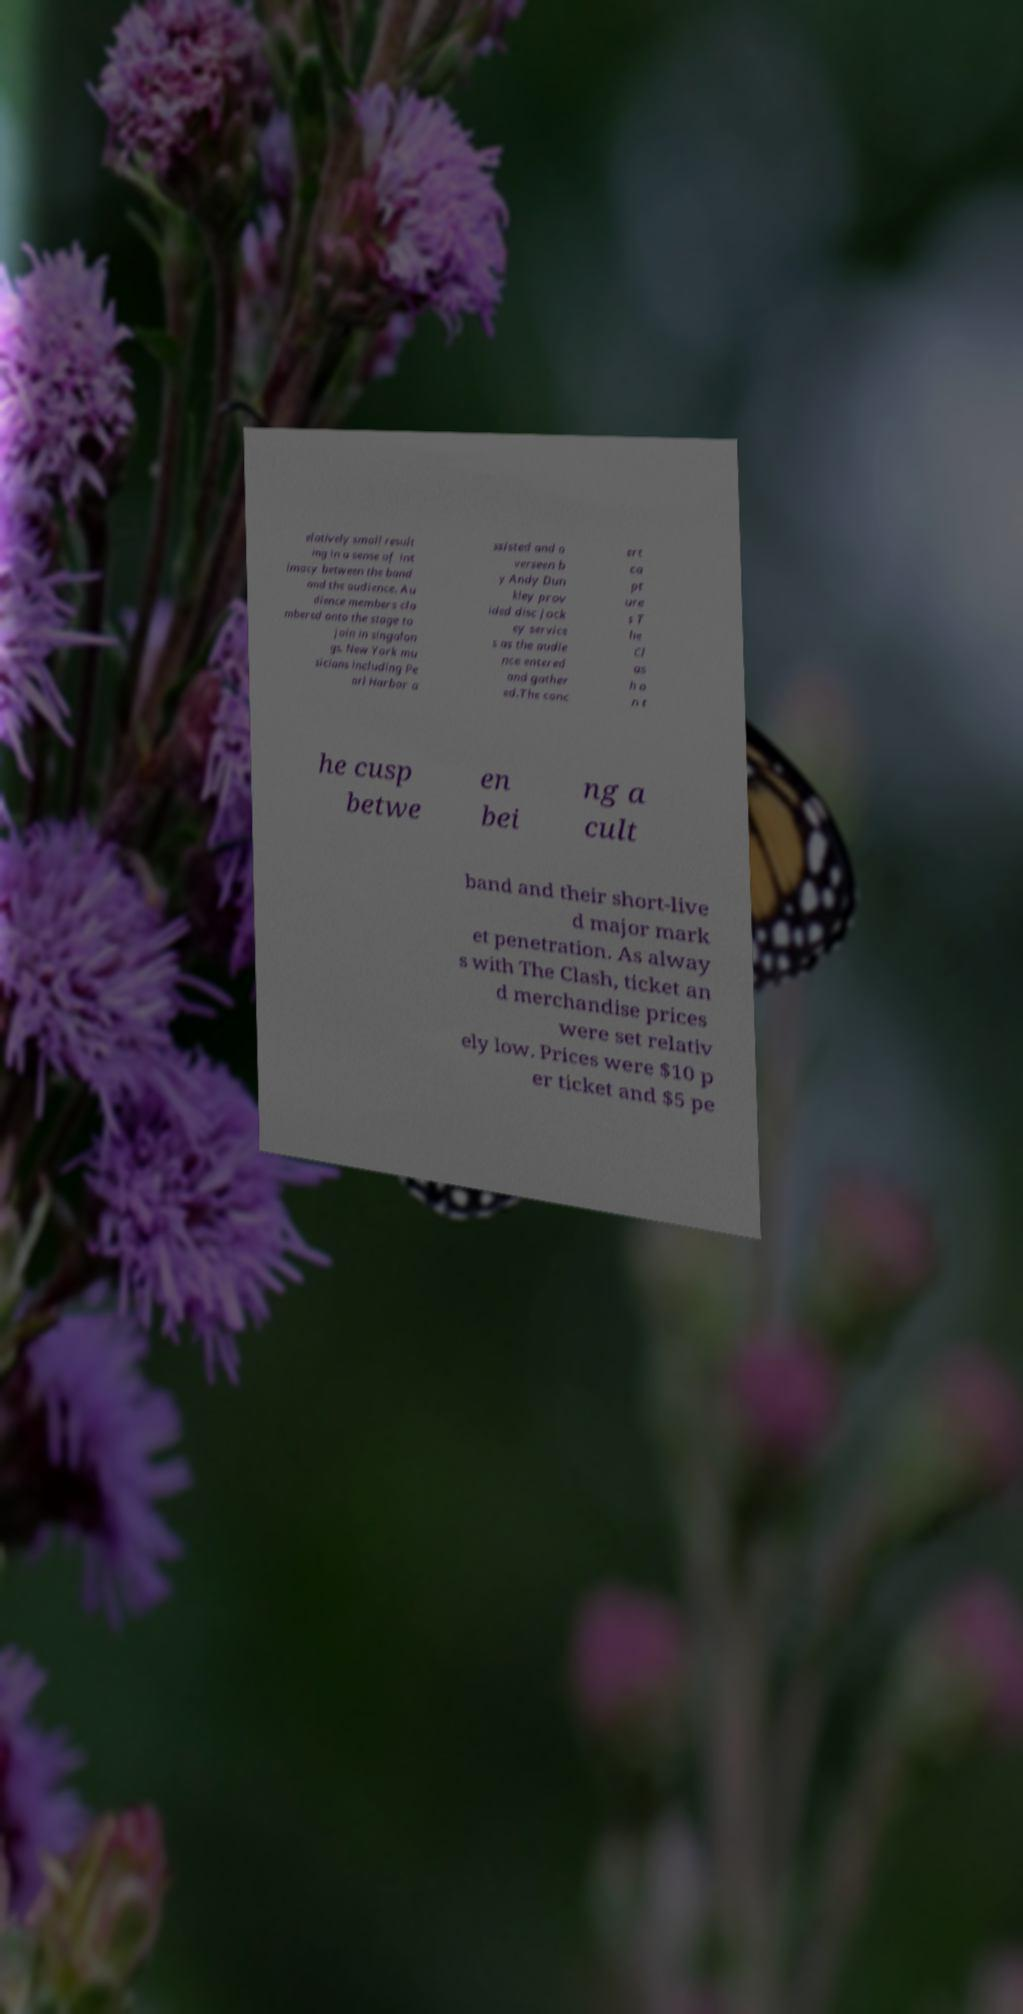Please read and relay the text visible in this image. What does it say? elatively small result ing in a sense of int imacy between the band and the audience. Au dience members cla mbered onto the stage to join in singalon gs. New York mu sicians including Pe arl Harbor a ssisted and o verseen b y Andy Dun kley prov ided disc jock ey service s as the audie nce entered and gather ed.The conc ert ca pt ure s T he Cl as h o n t he cusp betwe en bei ng a cult band and their short-live d major mark et penetration. As alway s with The Clash, ticket an d merchandise prices were set relativ ely low. Prices were $10 p er ticket and $5 pe 